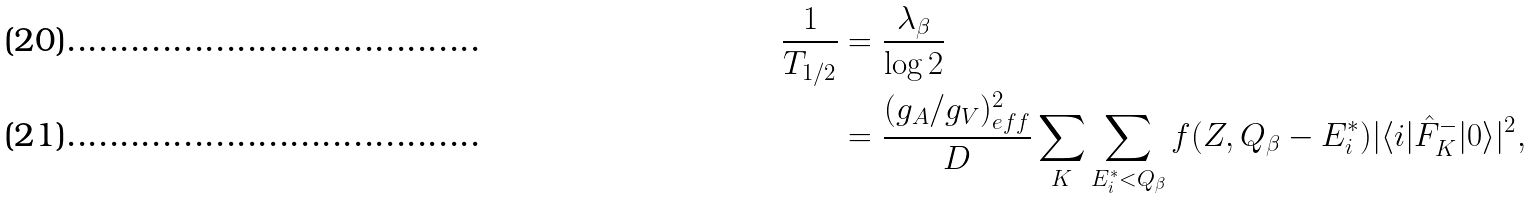Convert formula to latex. <formula><loc_0><loc_0><loc_500><loc_500>\frac { 1 } { T _ { 1 / 2 } } & = \frac { \lambda _ { \beta } } { \log 2 } \\ & = \frac { ( g _ { A } / g _ { V } ) ^ { 2 } _ { e f f } } { D } \sum _ { K } \sum _ { E _ { i } ^ { * } < Q _ { \beta } } f ( Z , Q _ { \beta } - E _ { i } ^ { * } ) | \langle i | \hat { F } _ { K } ^ { - } | 0 \rangle | ^ { 2 } ,</formula> 